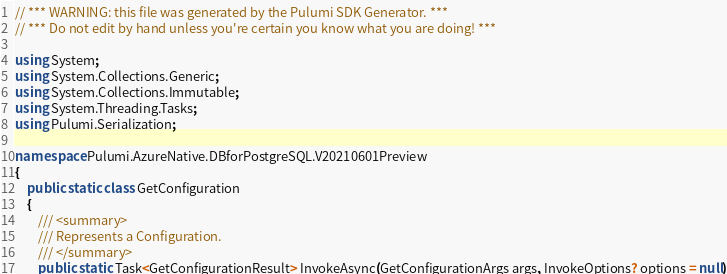Convert code to text. <code><loc_0><loc_0><loc_500><loc_500><_C#_>// *** WARNING: this file was generated by the Pulumi SDK Generator. ***
// *** Do not edit by hand unless you're certain you know what you are doing! ***

using System;
using System.Collections.Generic;
using System.Collections.Immutable;
using System.Threading.Tasks;
using Pulumi.Serialization;

namespace Pulumi.AzureNative.DBforPostgreSQL.V20210601Preview
{
    public static class GetConfiguration
    {
        /// <summary>
        /// Represents a Configuration.
        /// </summary>
        public static Task<GetConfigurationResult> InvokeAsync(GetConfigurationArgs args, InvokeOptions? options = null)</code> 